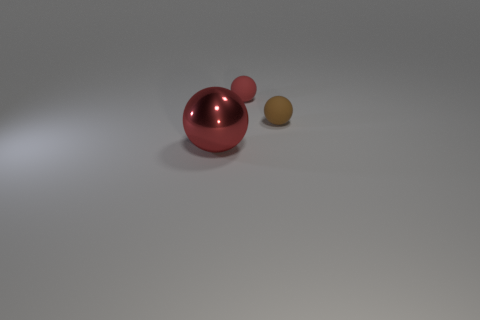Is there anything else that is made of the same material as the big red sphere?
Your answer should be compact. No. Are there any other things that have the same color as the large metallic object?
Keep it short and to the point. Yes. Is there anything else that has the same size as the shiny object?
Your answer should be very brief. No. How many things are small red spheres or brown rubber things?
Your response must be concise. 2. Are there any other red objects of the same size as the red rubber thing?
Ensure brevity in your answer.  No. Is the number of tiny brown objects that are to the left of the shiny thing greater than the number of tiny brown balls behind the small brown rubber thing?
Ensure brevity in your answer.  No. There is a big shiny object on the left side of the brown thing; is it the same color as the tiny rubber thing behind the brown rubber sphere?
Your answer should be compact. Yes. The brown thing that is the same size as the red matte thing is what shape?
Provide a succinct answer. Sphere. Is there a tiny red matte thing that has the same shape as the brown thing?
Ensure brevity in your answer.  Yes. Does the tiny sphere on the right side of the red rubber ball have the same material as the red ball that is on the right side of the big object?
Make the answer very short. Yes. 